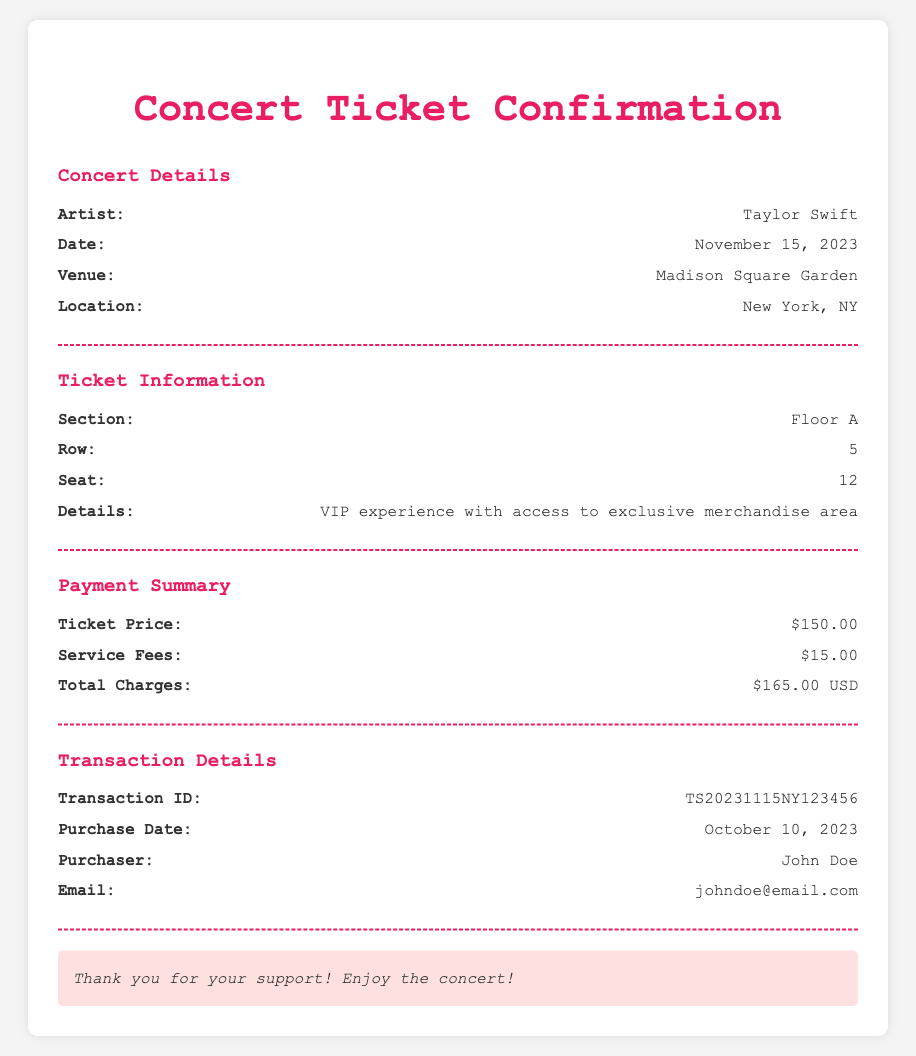What is the date of the concert? The concert date is explicitly mentioned in the document as November 15, 2023.
Answer: November 15, 2023 What is the venue of the concert? The venue is cited in the concert details section of the document as Madison Square Garden.
Answer: Madison Square Garden What is the artist's name? The name of the artist performing at the concert is clearly stated as Taylor Swift.
Answer: Taylor Swift What is the total charge for the ticket? The total charge is calculated in the payment summary section of the document as $165.00 USD.
Answer: $165.00 USD What row is the seat located in? The row number for the assigned seat is provided in the ticket information section as Row 5.
Answer: 5 What is the transaction ID? The transaction ID can be found in the transaction details section and is specified as TS20231115NY123456.
Answer: TS20231115NY123456 How many service fees are included? The service fees are listed in the payment summary as $15.00.
Answer: $15.00 What type of experience does the ticket grant access to? The ticket details mention a VIP experience with access to an exclusive merchandise area.
Answer: VIP experience with access to exclusive merchandise area 